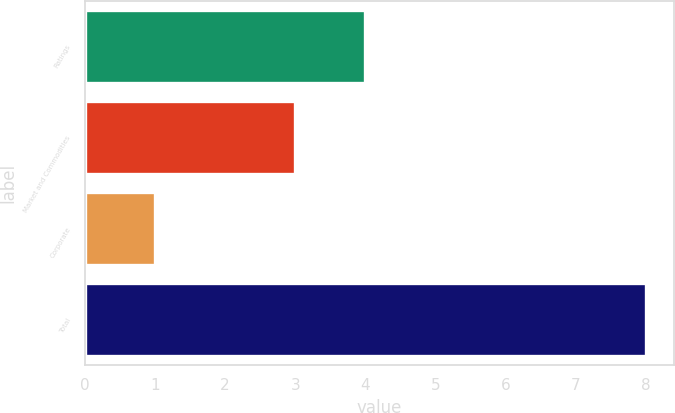<chart> <loc_0><loc_0><loc_500><loc_500><bar_chart><fcel>Ratings<fcel>Market and Commodities<fcel>Corporate<fcel>Total<nl><fcel>4<fcel>3<fcel>1<fcel>8<nl></chart> 